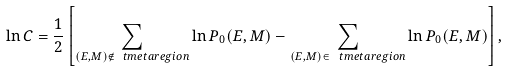<formula> <loc_0><loc_0><loc_500><loc_500>\ln C = \frac { 1 } { 2 } \left [ \sum _ { ( E , M ) \notin \ t m e t a r e g i o n } \ln P _ { 0 } ( E , M ) - \sum _ { ( E , M ) \in \ t m e t a r e g i o n } \ln P _ { 0 } ( E , M ) \right ] ,</formula> 